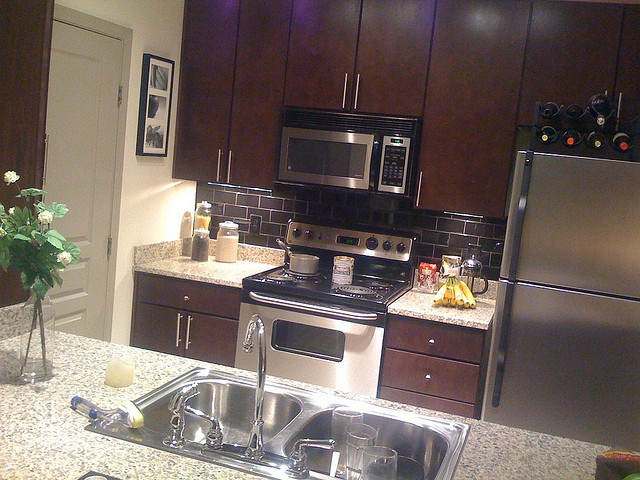Describe the objects in this image and their specific colors. I can see refrigerator in black and gray tones, sink in black, gray, darkgray, and white tones, oven in black, gray, white, and darkgray tones, microwave in black, gray, and darkgray tones, and vase in black, darkgray, gray, and tan tones in this image. 